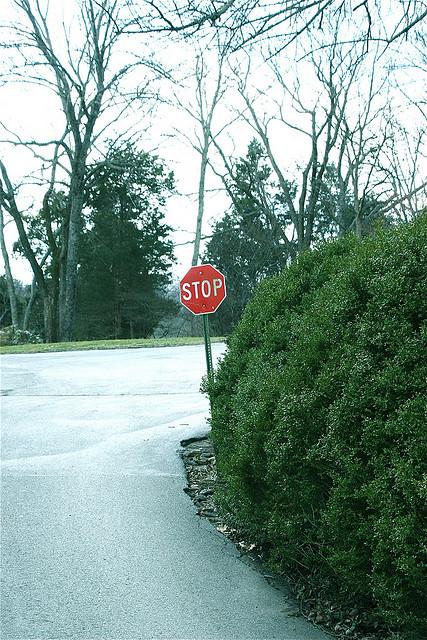What sign is that?
Give a very brief answer. Stop. Where is the bush?
Short answer required. On right. Can you see any vehicles coming around the corner?
Keep it brief. No. 